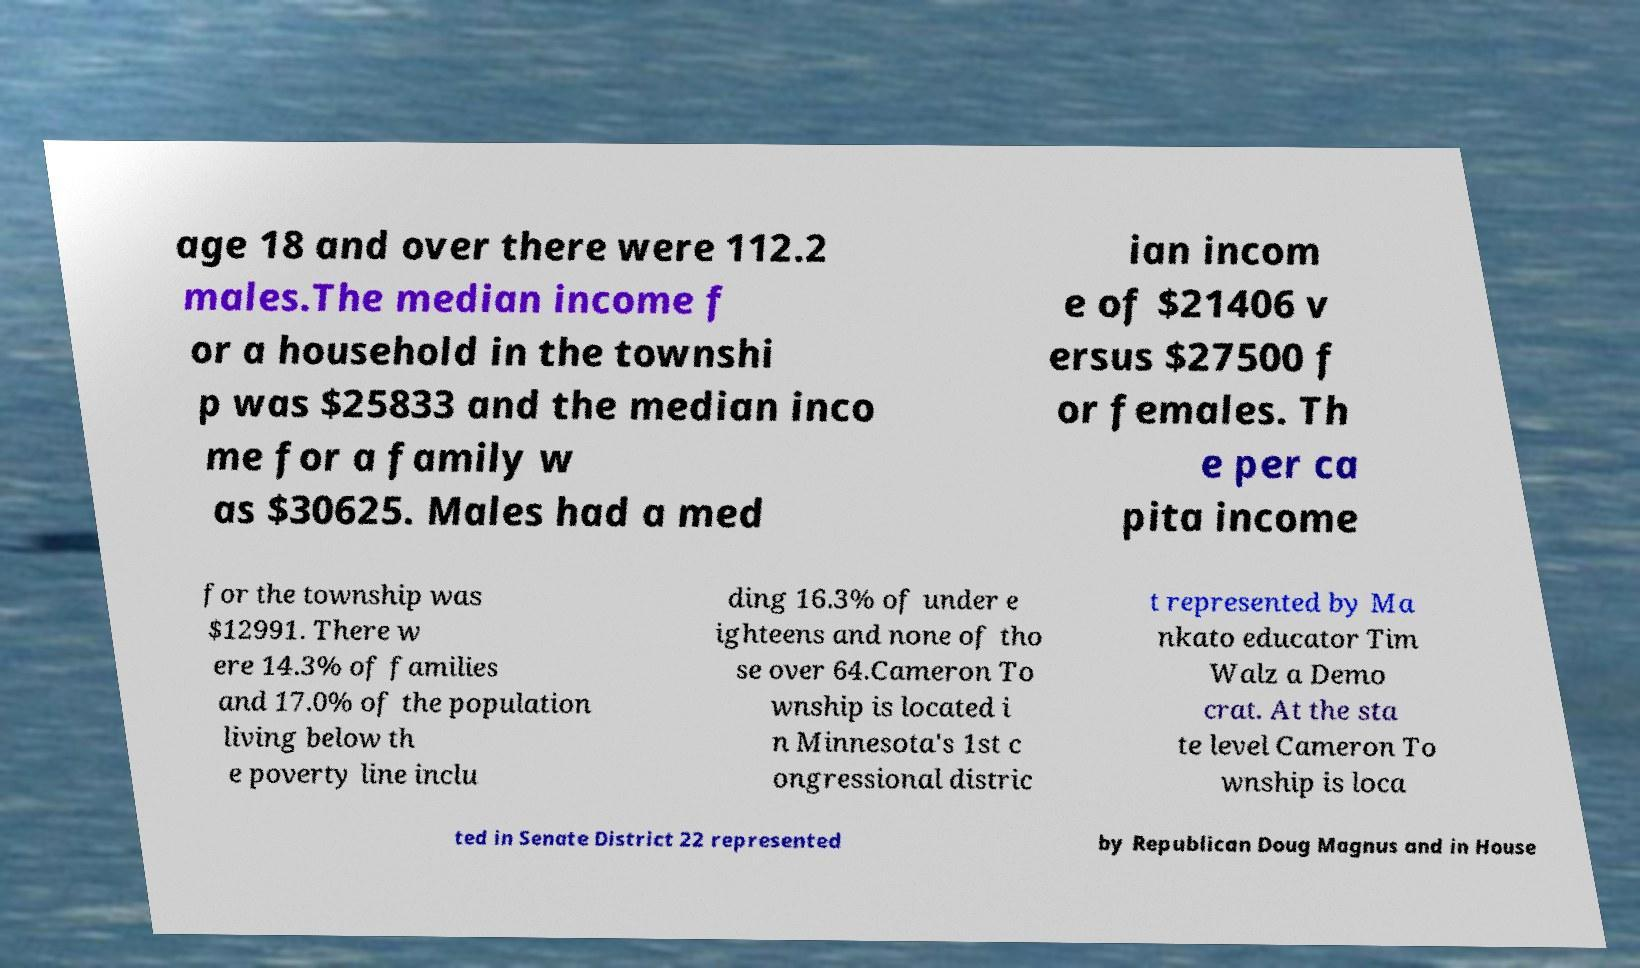What messages or text are displayed in this image? I need them in a readable, typed format. age 18 and over there were 112.2 males.The median income f or a household in the townshi p was $25833 and the median inco me for a family w as $30625. Males had a med ian incom e of $21406 v ersus $27500 f or females. Th e per ca pita income for the township was $12991. There w ere 14.3% of families and 17.0% of the population living below th e poverty line inclu ding 16.3% of under e ighteens and none of tho se over 64.Cameron To wnship is located i n Minnesota's 1st c ongressional distric t represented by Ma nkato educator Tim Walz a Demo crat. At the sta te level Cameron To wnship is loca ted in Senate District 22 represented by Republican Doug Magnus and in House 